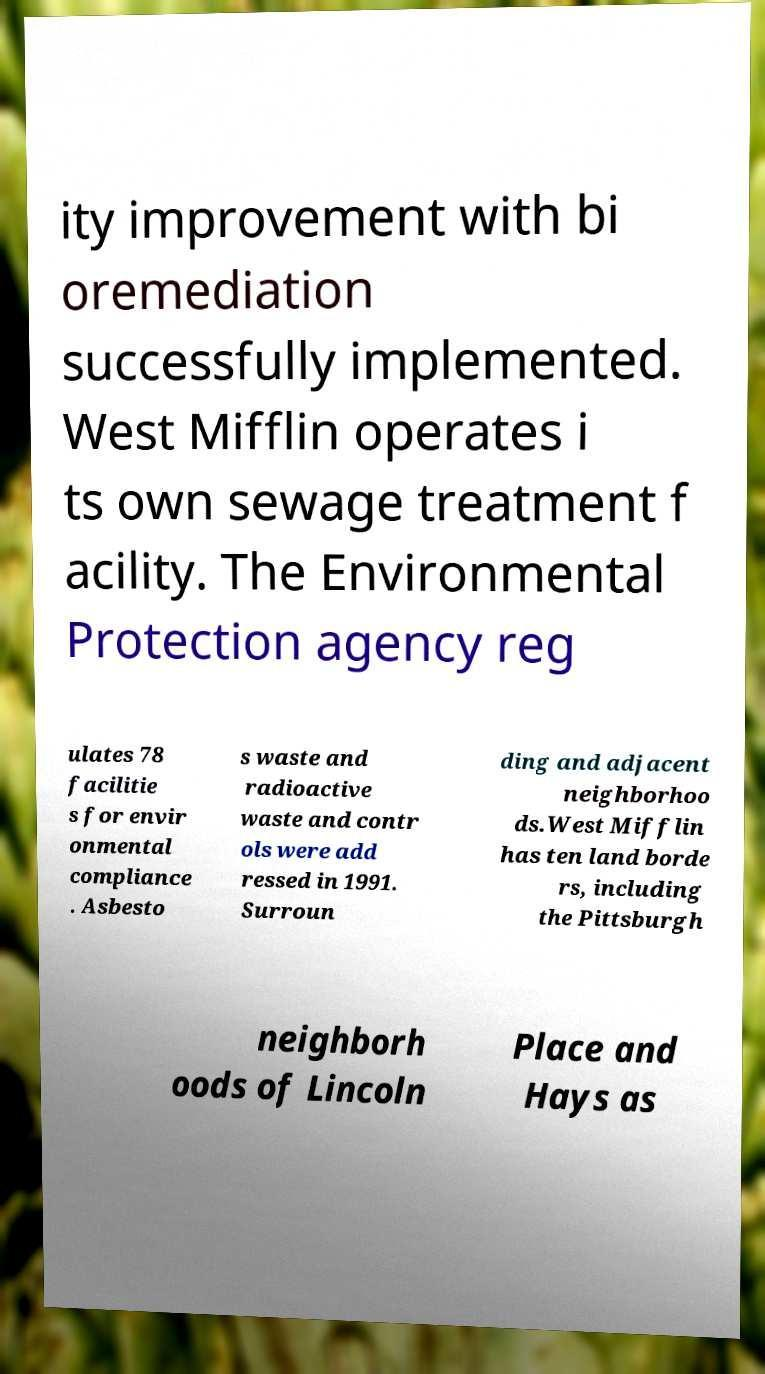Could you assist in decoding the text presented in this image and type it out clearly? ity improvement with bi oremediation successfully implemented. West Mifflin operates i ts own sewage treatment f acility. The Environmental Protection agency reg ulates 78 facilitie s for envir onmental compliance . Asbesto s waste and radioactive waste and contr ols were add ressed in 1991. Surroun ding and adjacent neighborhoo ds.West Mifflin has ten land borde rs, including the Pittsburgh neighborh oods of Lincoln Place and Hays as 